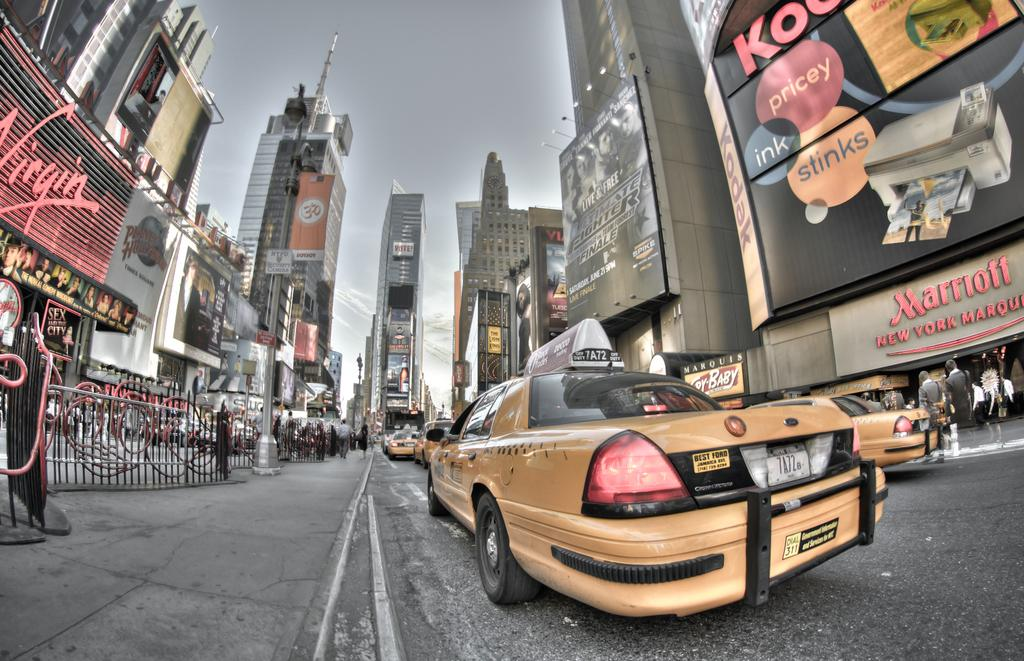<image>
Offer a succinct explanation of the picture presented. Yellow New York taxis are on the street in front of the Marriott Hotel. 